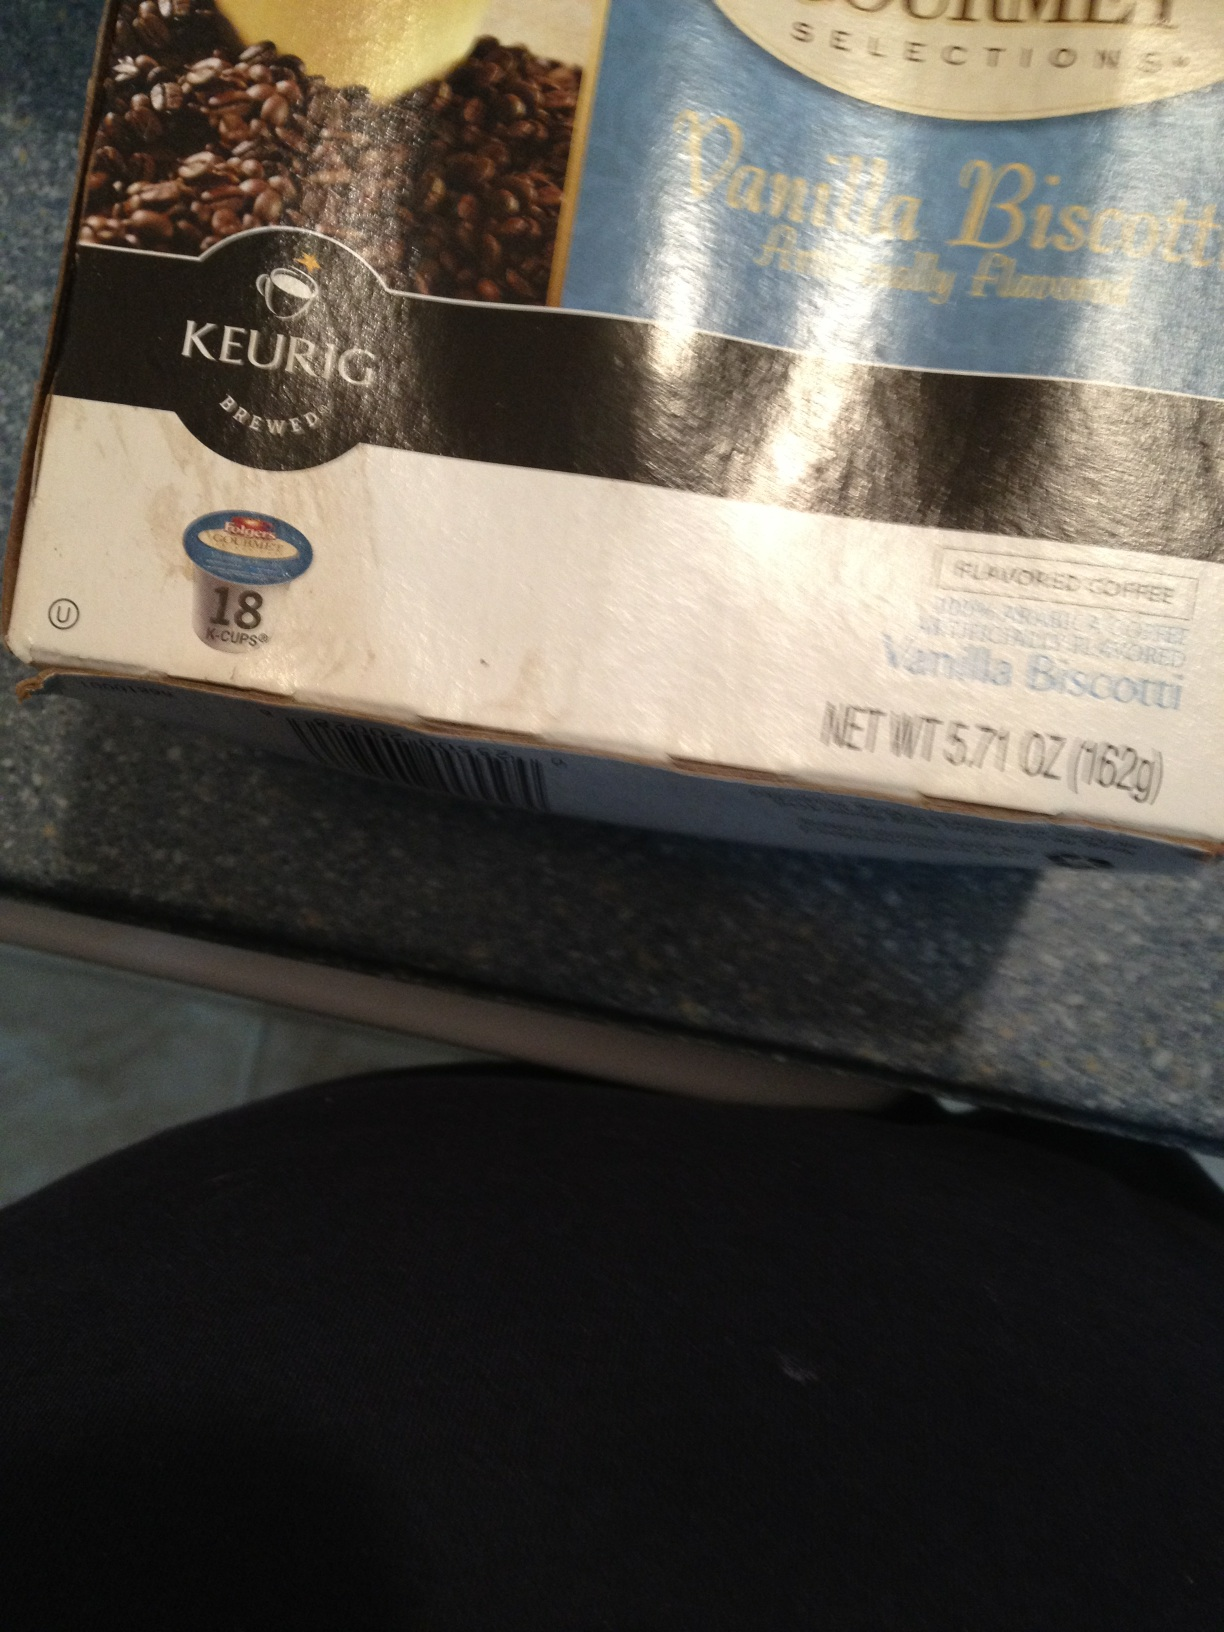What flavor is this? The flavor of this product is Vanilla Biscotti. It's a flavored coffee pod designed for Keurig brewing systems, offering a sweet and aromatic blend of vanilla and biscotti flavors. 